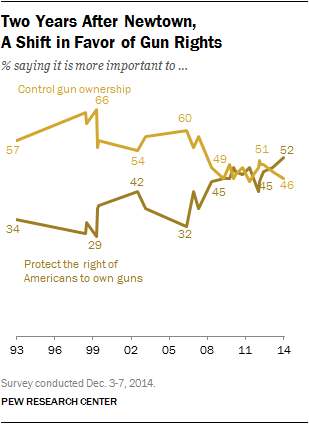Specify some key components in this picture. In 1999, there was a significant gap between those who believed it was important to control gun ownership and those who believed it was important to protect the rights of Americans to own guns. In 2014, a small percentage of people believed that controlling gun ownership was important, with 0.46% of the population expressing this view. 